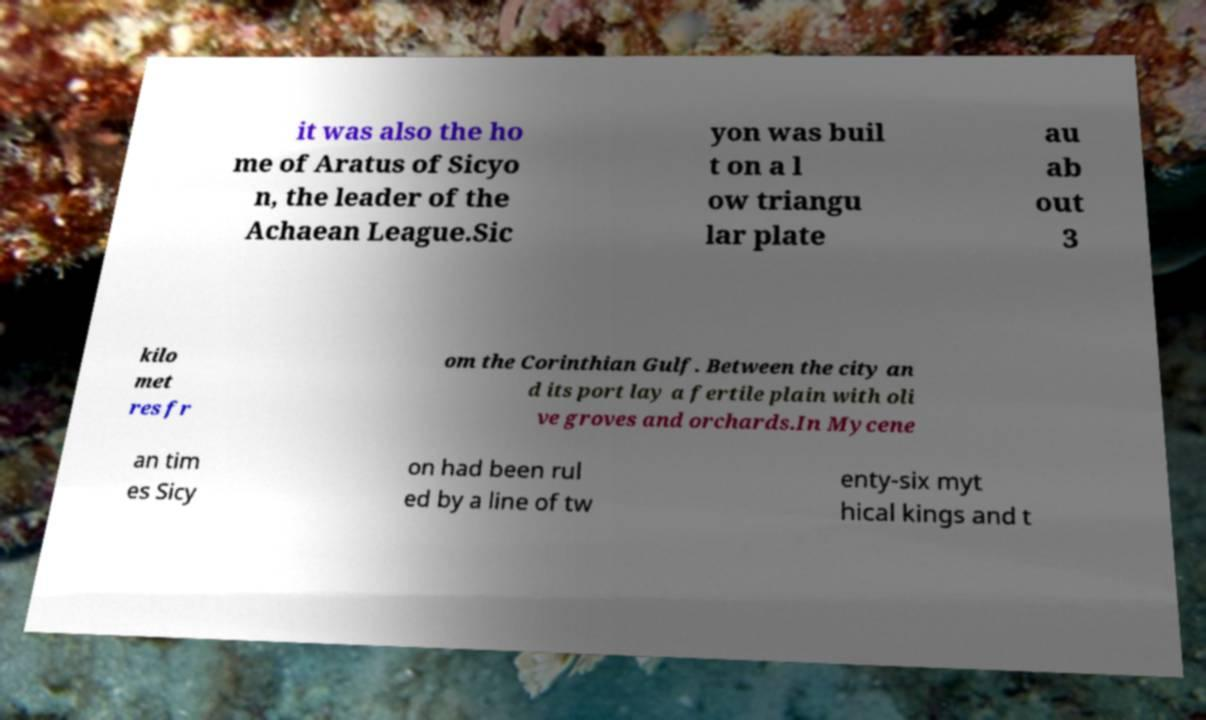Could you assist in decoding the text presented in this image and type it out clearly? it was also the ho me of Aratus of Sicyo n, the leader of the Achaean League.Sic yon was buil t on a l ow triangu lar plate au ab out 3 kilo met res fr om the Corinthian Gulf. Between the city an d its port lay a fertile plain with oli ve groves and orchards.In Mycene an tim es Sicy on had been rul ed by a line of tw enty-six myt hical kings and t 